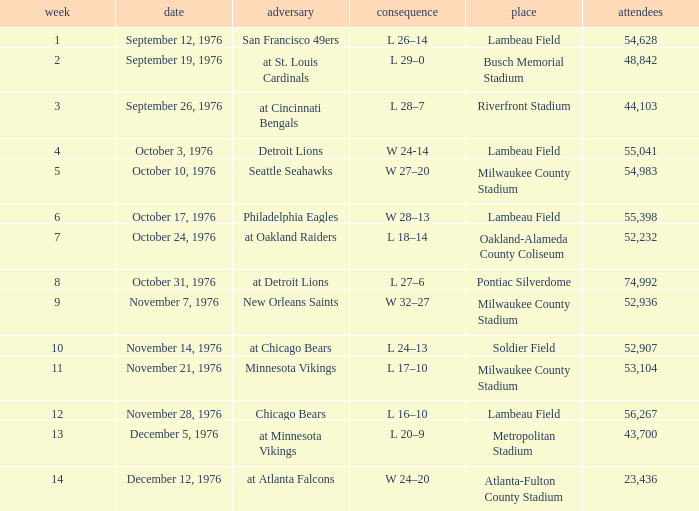How many people attended the game on September 19, 1976? 1.0. 